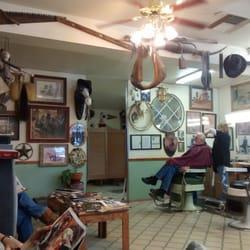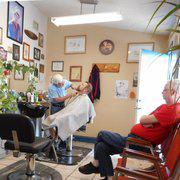The first image is the image on the left, the second image is the image on the right. Given the left and right images, does the statement "In one image, a male and a female barber are both working on seated customers, with an empty chair between them." hold true? Answer yes or no. No. 